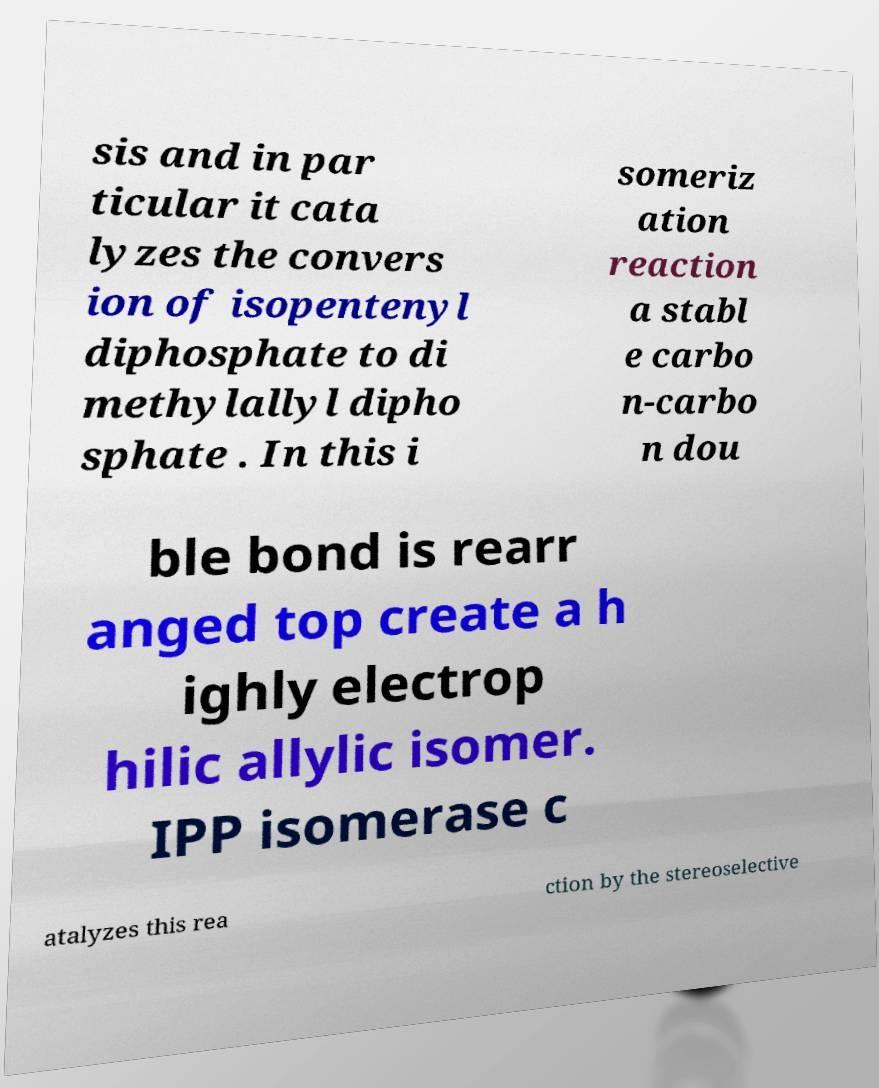Could you assist in decoding the text presented in this image and type it out clearly? sis and in par ticular it cata lyzes the convers ion of isopentenyl diphosphate to di methylallyl dipho sphate . In this i someriz ation reaction a stabl e carbo n-carbo n dou ble bond is rearr anged top create a h ighly electrop hilic allylic isomer. IPP isomerase c atalyzes this rea ction by the stereoselective 